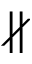Convert formula to latex. <formula><loc_0><loc_0><loc_500><loc_500>\nparallel</formula> 